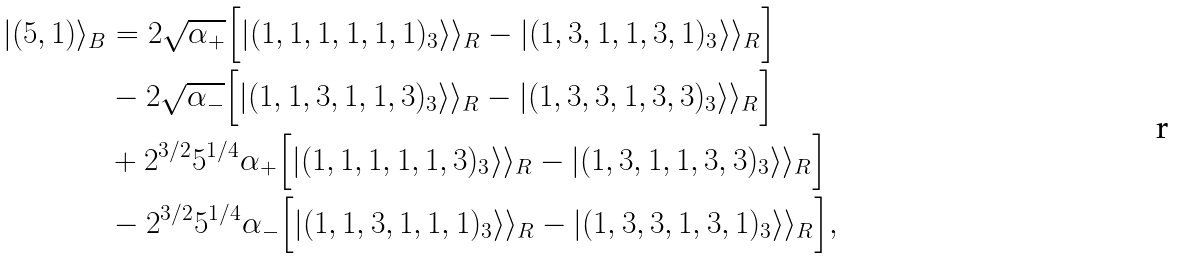Convert formula to latex. <formula><loc_0><loc_0><loc_500><loc_500>| ( 5 , 1 ) \rangle _ { B } & = 2 \sqrt { \alpha _ { + } } \Big { [ } | ( 1 , 1 , 1 , 1 , 1 , 1 ) _ { 3 } \rangle \rangle _ { R } - | ( 1 , 3 , 1 , 1 , 3 , 1 ) _ { 3 } \rangle \rangle _ { R } \Big { ] } \\ & - 2 \sqrt { \alpha _ { - } } \Big { [ } | ( 1 , 1 , 3 , 1 , 1 , 3 ) _ { 3 } \rangle \rangle _ { R } - | ( 1 , 3 , 3 , 1 , 3 , 3 ) _ { 3 } \rangle \rangle _ { R } \Big { ] } \\ & + 2 ^ { 3 / 2 } 5 ^ { 1 / 4 } \alpha _ { + } \Big { [ } | ( 1 , 1 , 1 , 1 , 1 , 3 ) _ { 3 } \rangle \rangle _ { R } - | ( 1 , 3 , 1 , 1 , 3 , 3 ) _ { 3 } \rangle \rangle _ { R } \Big { ] } \\ & - 2 ^ { 3 / 2 } 5 ^ { 1 / 4 } \alpha _ { - } \Big { [ } | ( 1 , 1 , 3 , 1 , 1 , 1 ) _ { 3 } \rangle \rangle _ { R } - | ( 1 , 3 , 3 , 1 , 3 , 1 ) _ { 3 } \rangle \rangle _ { R } \Big { ] } ,</formula> 